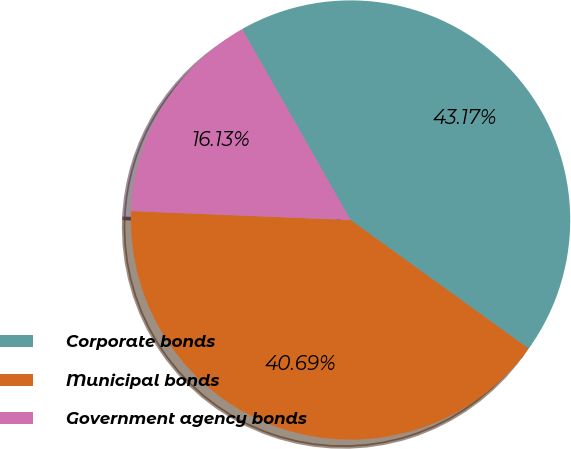Convert chart to OTSL. <chart><loc_0><loc_0><loc_500><loc_500><pie_chart><fcel>Corporate bonds<fcel>Municipal bonds<fcel>Government agency bonds<nl><fcel>43.17%<fcel>40.69%<fcel>16.13%<nl></chart> 